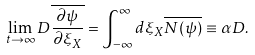<formula> <loc_0><loc_0><loc_500><loc_500>\lim _ { t \rightarrow \infty } D \overline { { \frac { \partial \psi } { \partial \xi _ { X } } } } = \int _ { - \infty } ^ { \infty } d \xi _ { X } \overline { N ( \psi ) } \equiv \alpha D .</formula> 